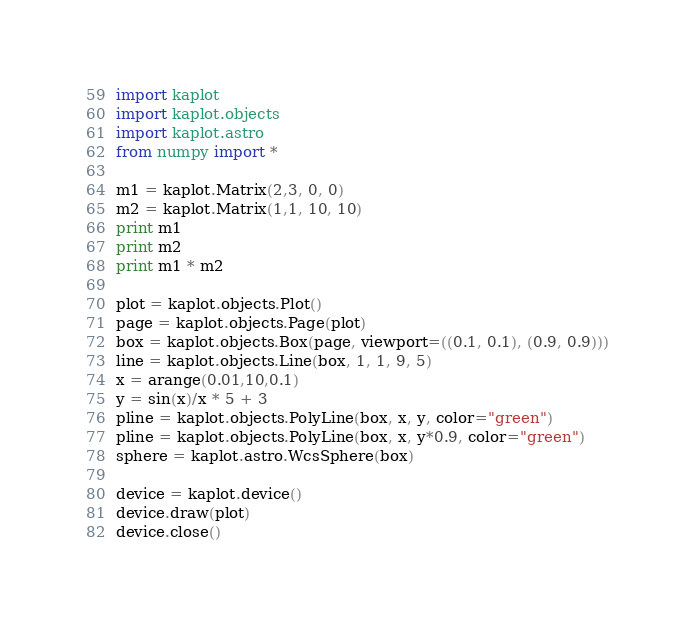<code> <loc_0><loc_0><loc_500><loc_500><_Python_>import kaplot
import kaplot.objects
import kaplot.astro
from numpy import *

m1 = kaplot.Matrix(2,3, 0, 0)
m2 = kaplot.Matrix(1,1, 10, 10)
print m1
print m2
print m1 * m2

plot = kaplot.objects.Plot()
page = kaplot.objects.Page(plot)
box = kaplot.objects.Box(page, viewport=((0.1, 0.1), (0.9, 0.9)))
line = kaplot.objects.Line(box, 1, 1, 9, 5)
x = arange(0.01,10,0.1)
y = sin(x)/x * 5 + 3
pline = kaplot.objects.PolyLine(box, x, y, color="green")
pline = kaplot.objects.PolyLine(box, x, y*0.9, color="green")
sphere = kaplot.astro.WcsSphere(box)

device = kaplot.device()
device.draw(plot)
device.close()
</code> 